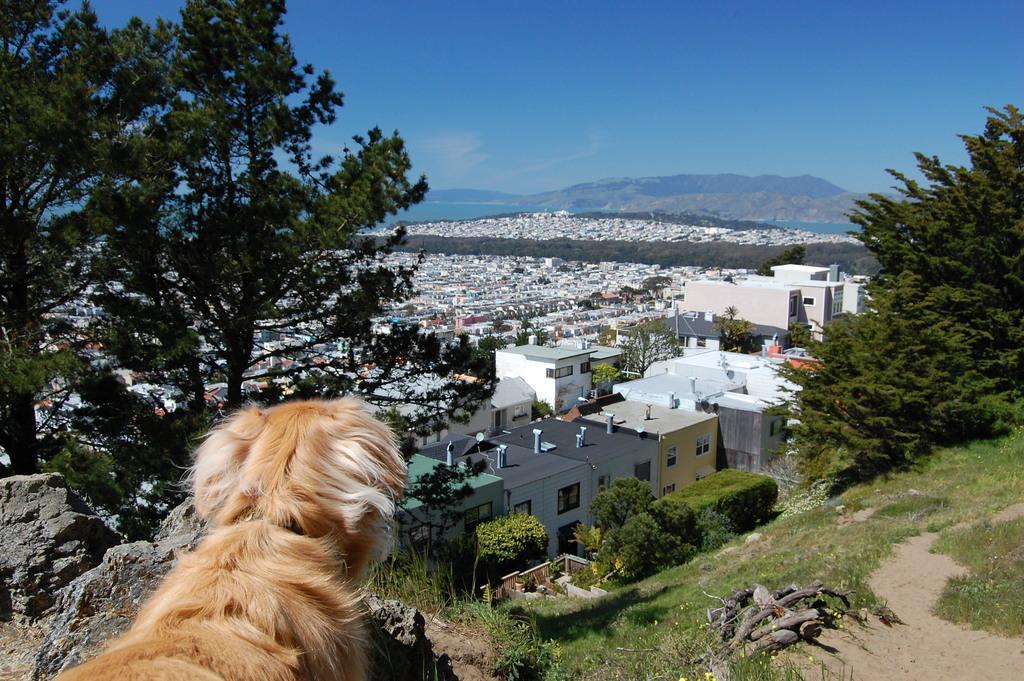How would you summarize this image in a sentence or two? As we can see in the image there are trees, grass, dog, buildings, plants and on the top there is sky. 